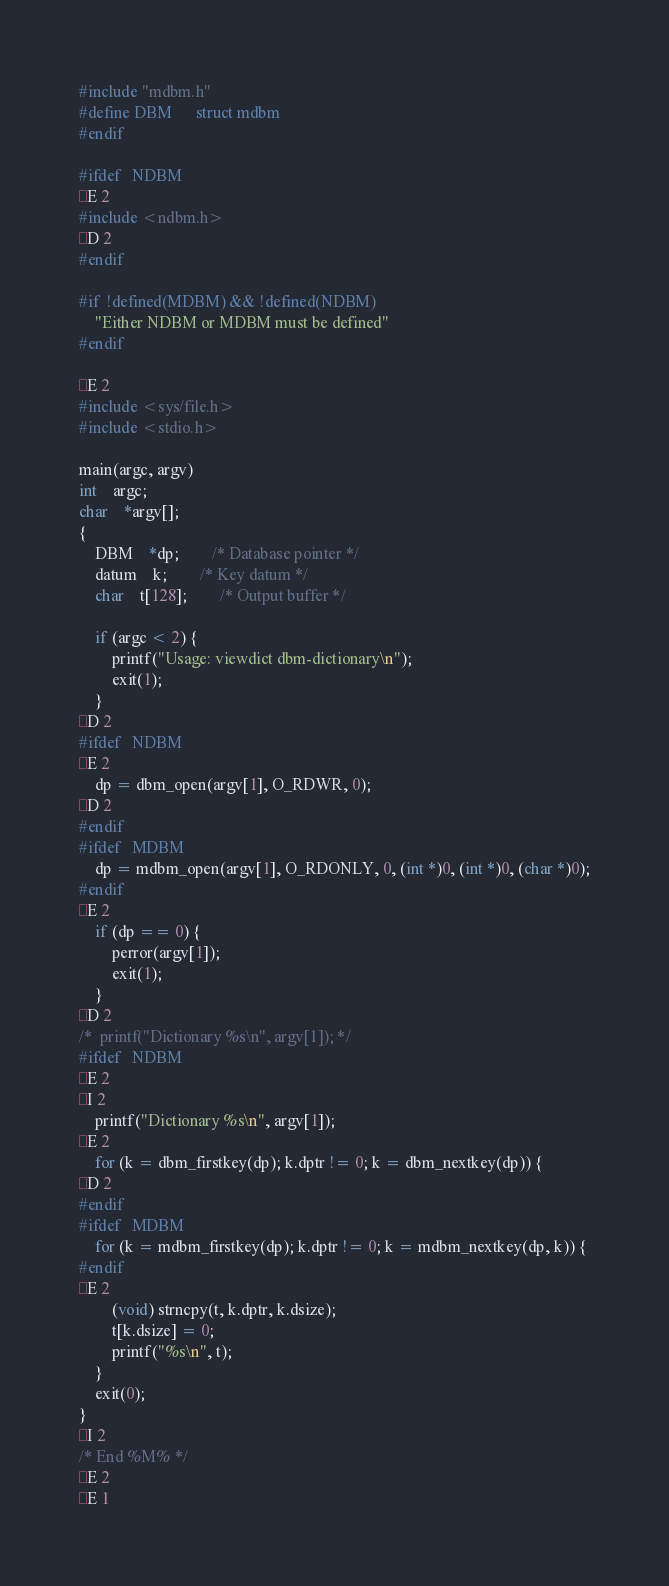<code> <loc_0><loc_0><loc_500><loc_500><_C_>#include "mdbm.h"
#define DBM		struct mdbm
#endif

#ifdef	NDBM
E 2
#include <ndbm.h>
D 2
#endif

#if	!defined(MDBM) && !defined(NDBM)
	"Either NDBM or MDBM must be defined"
#endif

E 2
#include <sys/file.h>
#include <stdio.h>

main(argc, argv)
int	argc;
char	*argv[];
{
	DBM	*dp;		/* Database pointer */
	datum	k;		/* Key datum */
	char	t[128];		/* Output buffer */

	if (argc < 2) {
		printf("Usage: viewdict dbm-dictionary\n");
		exit(1);
	}
D 2
#ifdef	NDBM
E 2
	dp = dbm_open(argv[1], O_RDWR, 0);
D 2
#endif
#ifdef	MDBM
	dp = mdbm_open(argv[1], O_RDONLY, 0, (int *)0, (int *)0, (char *)0);
#endif
E 2
	if (dp == 0) {
		perror(argv[1]);
		exit(1);
	}
D 2
/* 	printf("Dictionary %s\n", argv[1]); */
#ifdef	NDBM
E 2
I 2
	printf("Dictionary %s\n", argv[1]);
E 2
	for (k = dbm_firstkey(dp); k.dptr != 0; k = dbm_nextkey(dp)) {
D 2
#endif
#ifdef	MDBM
	for (k = mdbm_firstkey(dp); k.dptr != 0; k = mdbm_nextkey(dp, k)) {
#endif
E 2
		(void) strncpy(t, k.dptr, k.dsize);
		t[k.dsize] = 0;
		printf("%s\n", t);
	}
	exit(0);
}
I 2
/* End %M% */
E 2
E 1
</code> 